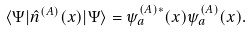<formula> <loc_0><loc_0><loc_500><loc_500>\langle \Psi | \hat { n } ^ { ( A ) } ( x ) | \Psi \rangle = \psi ^ { ( A ) * } _ { a } ( x ) \psi ^ { ( A ) } _ { a } ( x ) .</formula> 